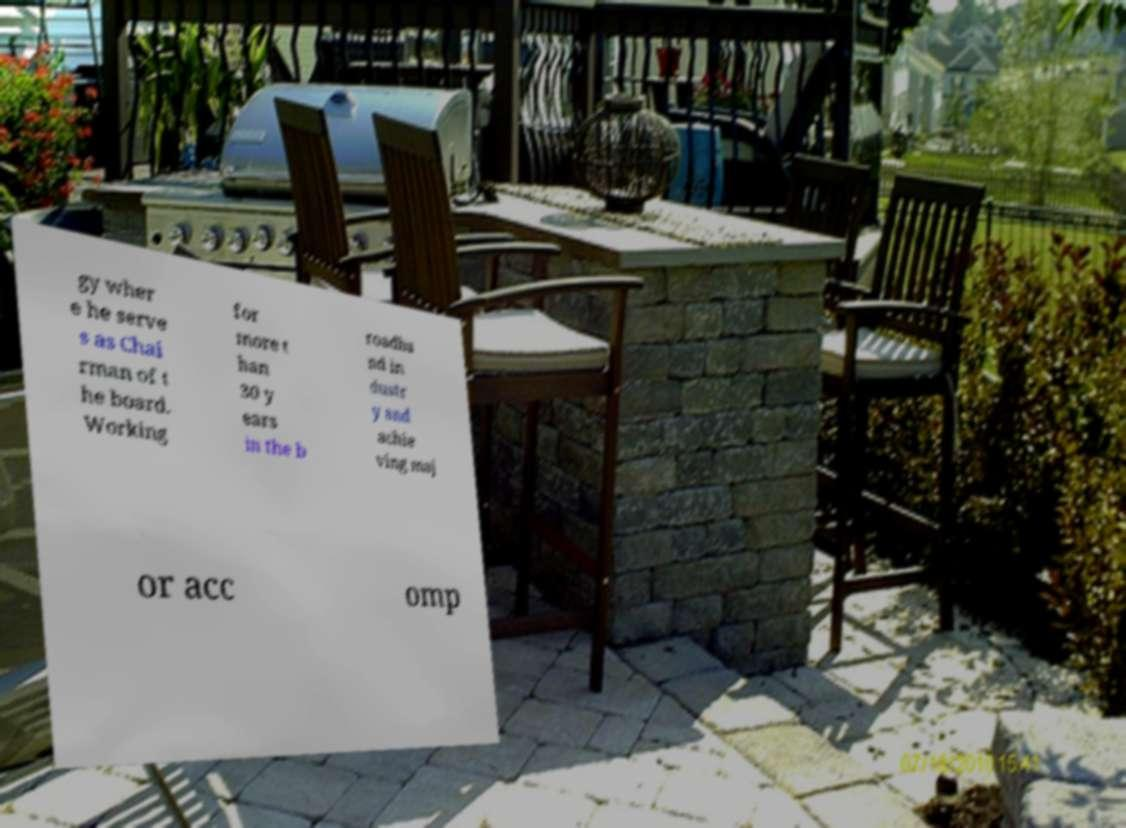Please identify and transcribe the text found in this image. gy wher e he serve s as Chai rman of t he board. Working for more t han 30 y ears in the b roadba nd in dustr y and achie ving maj or acc omp 